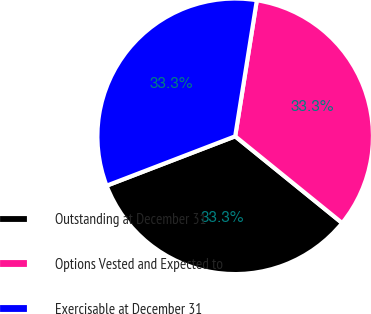Convert chart. <chart><loc_0><loc_0><loc_500><loc_500><pie_chart><fcel>Outstanding at December 31<fcel>Options Vested and Expected to<fcel>Exercisable at December 31<nl><fcel>33.32%<fcel>33.33%<fcel>33.35%<nl></chart> 